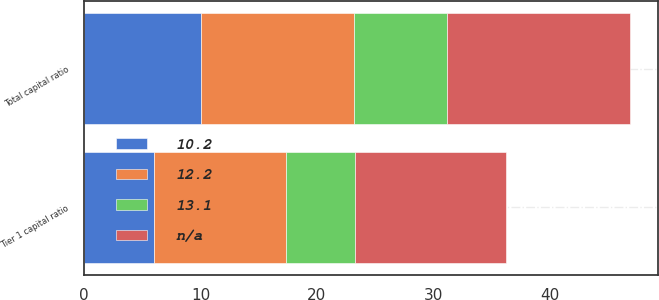Convert chart to OTSL. <chart><loc_0><loc_0><loc_500><loc_500><stacked_bar_chart><ecel><fcel>Tier 1 capital ratio<fcel>Total capital ratio<nl><fcel>nan<fcel>12.9<fcel>15.7<nl><fcel>12.2<fcel>11.3<fcel>13.2<nl><fcel>13.1<fcel>6<fcel>8<nl><fcel>10.2<fcel>6<fcel>10<nl></chart> 